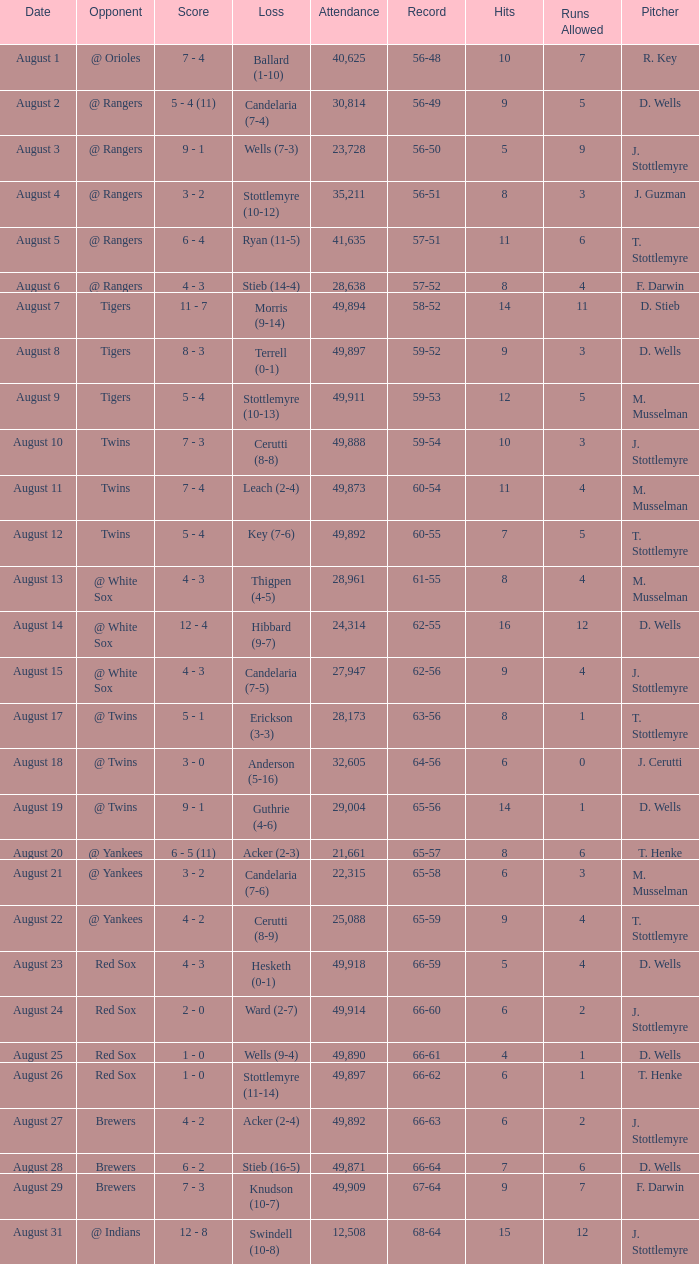What was the record of the game that had a loss of Stottlemyre (10-12)? 56-51. 